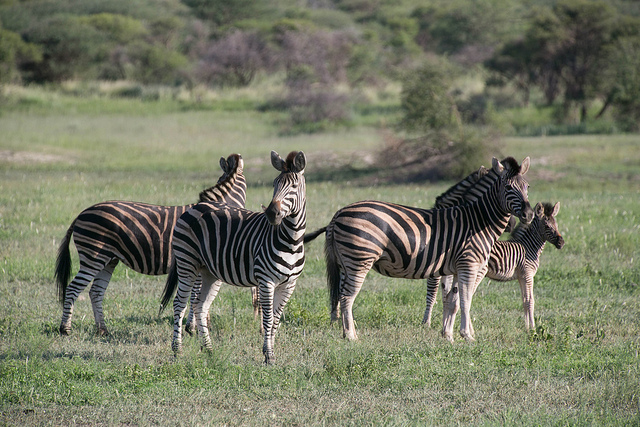<image>Where is the antelope? There is no antelope in the image. Where is the antelope? There is no antelope in the image. 